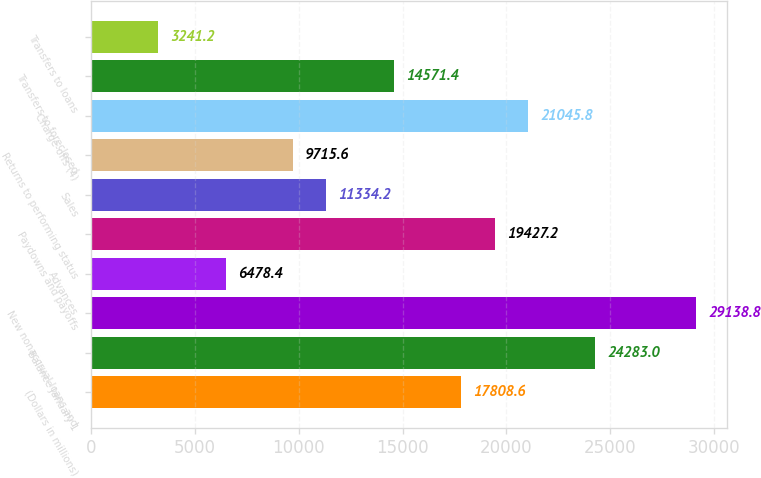Convert chart. <chart><loc_0><loc_0><loc_500><loc_500><bar_chart><fcel>(Dollars in millions)<fcel>Balance January 1<fcel>New nonaccrual loans and<fcel>Advances<fcel>Paydowns and payoffs<fcel>Sales<fcel>Returns to performing status<fcel>Charge-offs (4)<fcel>Transfers to foreclosed<fcel>Transfers to loans<nl><fcel>17808.6<fcel>24283<fcel>29138.8<fcel>6478.4<fcel>19427.2<fcel>11334.2<fcel>9715.6<fcel>21045.8<fcel>14571.4<fcel>3241.2<nl></chart> 